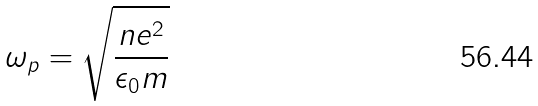Convert formula to latex. <formula><loc_0><loc_0><loc_500><loc_500>\omega _ { p } = \sqrt { \frac { n e ^ { 2 } } { \epsilon _ { 0 } m } }</formula> 